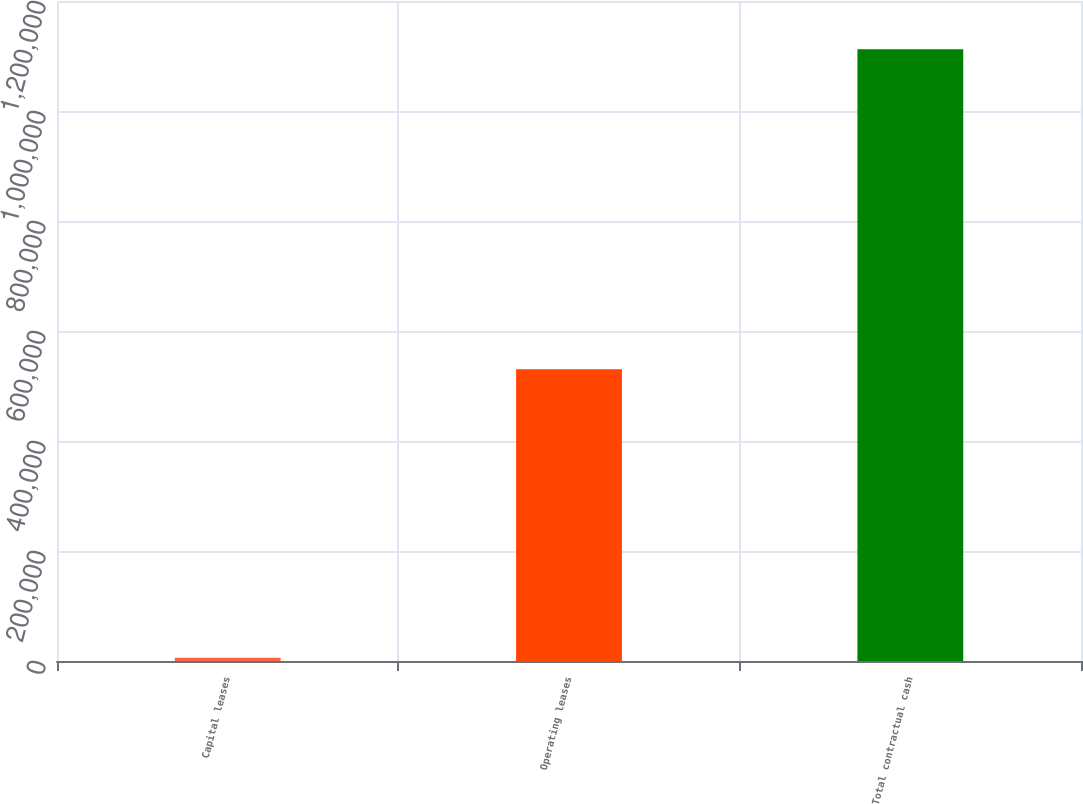Convert chart. <chart><loc_0><loc_0><loc_500><loc_500><bar_chart><fcel>Capital leases<fcel>Operating leases<fcel>Total contractual cash<nl><fcel>6069<fcel>530608<fcel>1.11226e+06<nl></chart> 